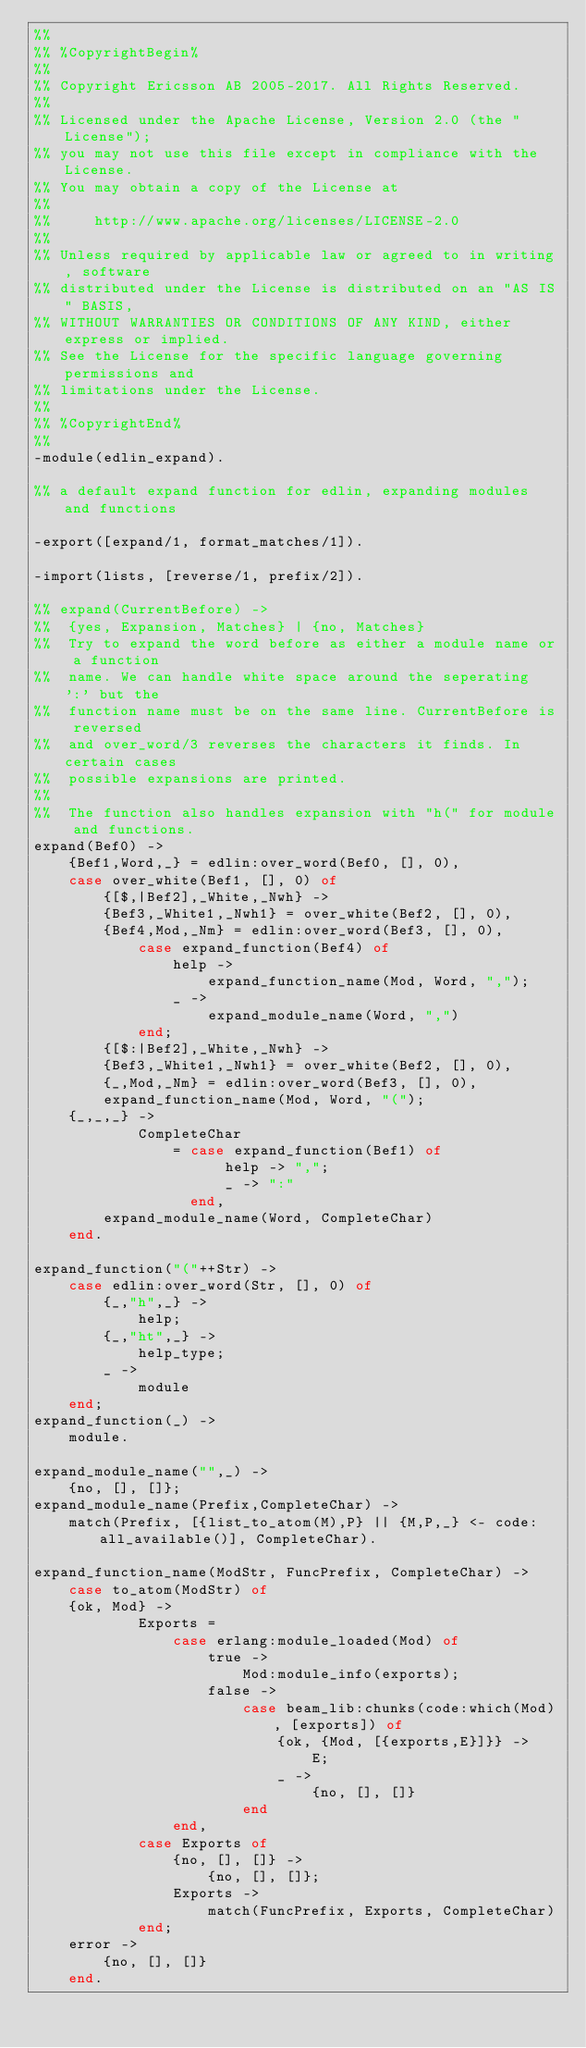Convert code to text. <code><loc_0><loc_0><loc_500><loc_500><_Erlang_>%%
%% %CopyrightBegin%
%%
%% Copyright Ericsson AB 2005-2017. All Rights Reserved.
%%
%% Licensed under the Apache License, Version 2.0 (the "License");
%% you may not use this file except in compliance with the License.
%% You may obtain a copy of the License at
%%
%%     http://www.apache.org/licenses/LICENSE-2.0
%%
%% Unless required by applicable law or agreed to in writing, software
%% distributed under the License is distributed on an "AS IS" BASIS,
%% WITHOUT WARRANTIES OR CONDITIONS OF ANY KIND, either express or implied.
%% See the License for the specific language governing permissions and
%% limitations under the License.
%%
%% %CopyrightEnd%
%%
-module(edlin_expand).

%% a default expand function for edlin, expanding modules and functions

-export([expand/1, format_matches/1]).

-import(lists, [reverse/1, prefix/2]).

%% expand(CurrentBefore) ->
%%	{yes, Expansion, Matches} | {no, Matches}
%%  Try to expand the word before as either a module name or a function
%%  name. We can handle white space around the seperating ':' but the
%%  function name must be on the same line. CurrentBefore is reversed
%%  and over_word/3 reverses the characters it finds. In certain cases
%%  possible expansions are printed.
%%
%%  The function also handles expansion with "h(" for module and functions.
expand(Bef0) ->
    {Bef1,Word,_} = edlin:over_word(Bef0, [], 0),
    case over_white(Bef1, [], 0) of
        {[$,|Bef2],_White,_Nwh} ->
	    {Bef3,_White1,_Nwh1} = over_white(Bef2, [], 0),
	    {Bef4,Mod,_Nm} = edlin:over_word(Bef3, [], 0),
            case expand_function(Bef4) of
                help ->
                    expand_function_name(Mod, Word, ",");
                _ ->
                    expand_module_name(Word, ",")
            end;
        {[$:|Bef2],_White,_Nwh} ->
 	    {Bef3,_White1,_Nwh1} = over_white(Bef2, [], 0),
 	    {_,Mod,_Nm} = edlin:over_word(Bef3, [], 0),
	    expand_function_name(Mod, Word, "(");
 	{_,_,_} ->
            CompleteChar
                = case expand_function(Bef1) of
                      help -> ",";
                      _ -> ":"
                  end,
	    expand_module_name(Word, CompleteChar)
    end.

expand_function("("++Str) ->
    case edlin:over_word(Str, [], 0) of
        {_,"h",_} ->
            help;
        {_,"ht",_} ->
            help_type;
        _ ->
            module
    end;
expand_function(_) ->
    module.

expand_module_name("",_) ->
    {no, [], []};
expand_module_name(Prefix,CompleteChar) ->
    match(Prefix, [{list_to_atom(M),P} || {M,P,_} <- code:all_available()], CompleteChar).

expand_function_name(ModStr, FuncPrefix, CompleteChar) ->
    case to_atom(ModStr) of
	{ok, Mod} ->
            Exports =
                case erlang:module_loaded(Mod) of
                    true ->
                        Mod:module_info(exports);
                    false ->
                        case beam_lib:chunks(code:which(Mod), [exports]) of
                            {ok, {Mod, [{exports,E}]}} ->
                                E;
                            _ ->
                                {no, [], []}
                        end
                end,
            case Exports of
                {no, [], []} ->
                    {no, [], []};
                Exports ->
                    match(FuncPrefix, Exports, CompleteChar)
            end;
	error ->
	    {no, [], []}
    end.
</code> 